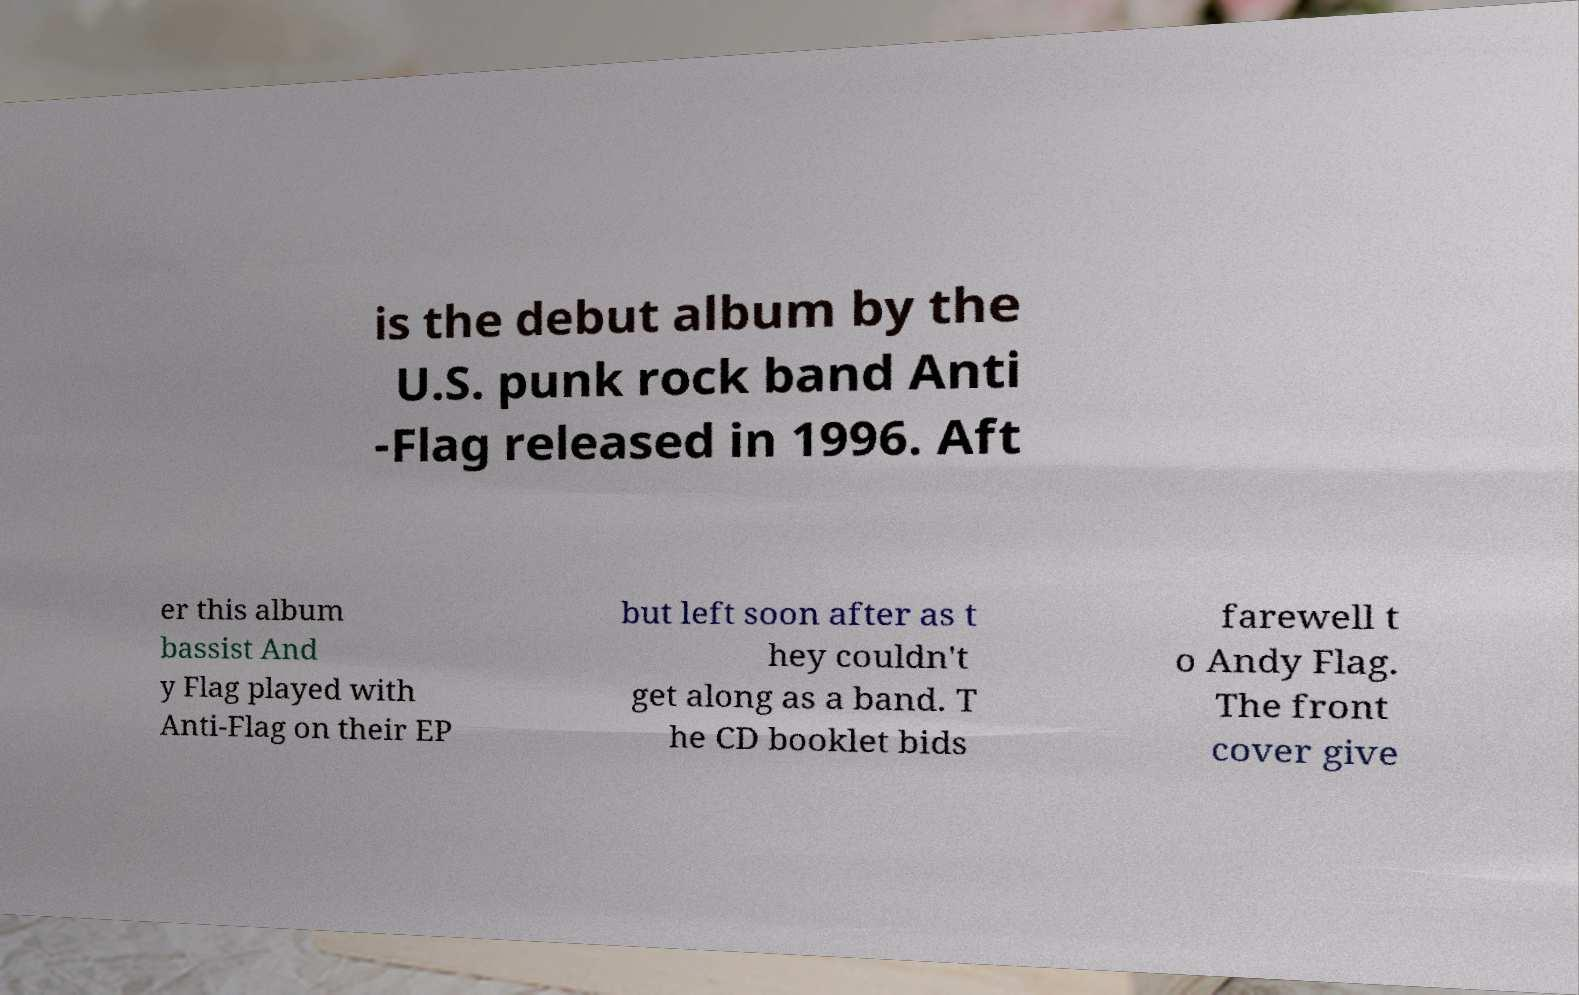What messages or text are displayed in this image? I need them in a readable, typed format. is the debut album by the U.S. punk rock band Anti -Flag released in 1996. Aft er this album bassist And y Flag played with Anti-Flag on their EP but left soon after as t hey couldn't get along as a band. T he CD booklet bids farewell t o Andy Flag. The front cover give 